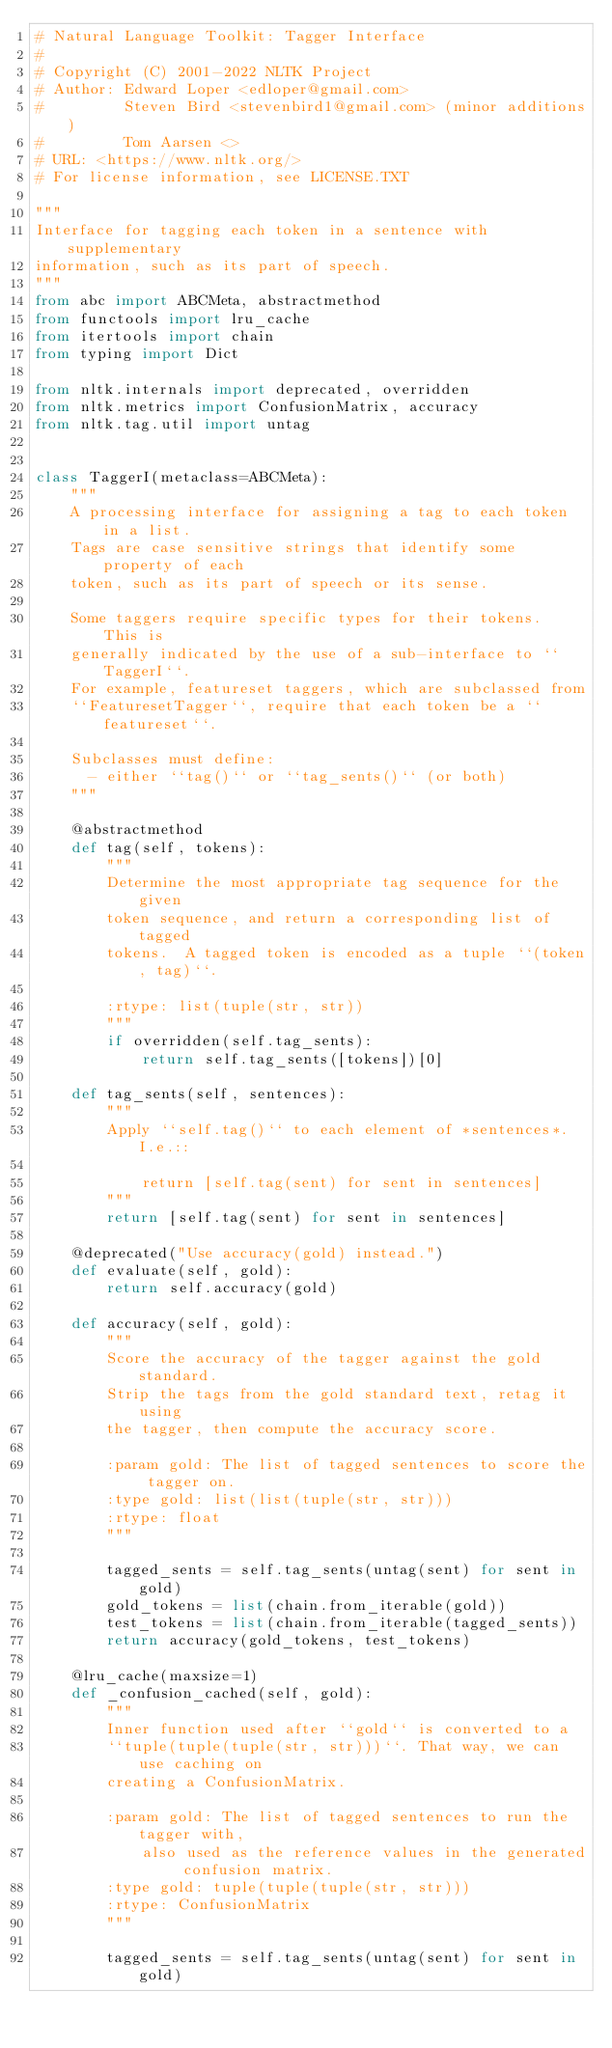Convert code to text. <code><loc_0><loc_0><loc_500><loc_500><_Python_># Natural Language Toolkit: Tagger Interface
#
# Copyright (C) 2001-2022 NLTK Project
# Author: Edward Loper <edloper@gmail.com>
#         Steven Bird <stevenbird1@gmail.com> (minor additions)
#         Tom Aarsen <>
# URL: <https://www.nltk.org/>
# For license information, see LICENSE.TXT

"""
Interface for tagging each token in a sentence with supplementary
information, such as its part of speech.
"""
from abc import ABCMeta, abstractmethod
from functools import lru_cache
from itertools import chain
from typing import Dict

from nltk.internals import deprecated, overridden
from nltk.metrics import ConfusionMatrix, accuracy
from nltk.tag.util import untag


class TaggerI(metaclass=ABCMeta):
    """
    A processing interface for assigning a tag to each token in a list.
    Tags are case sensitive strings that identify some property of each
    token, such as its part of speech or its sense.

    Some taggers require specific types for their tokens.  This is
    generally indicated by the use of a sub-interface to ``TaggerI``.
    For example, featureset taggers, which are subclassed from
    ``FeaturesetTagger``, require that each token be a ``featureset``.

    Subclasses must define:
      - either ``tag()`` or ``tag_sents()`` (or both)
    """

    @abstractmethod
    def tag(self, tokens):
        """
        Determine the most appropriate tag sequence for the given
        token sequence, and return a corresponding list of tagged
        tokens.  A tagged token is encoded as a tuple ``(token, tag)``.

        :rtype: list(tuple(str, str))
        """
        if overridden(self.tag_sents):
            return self.tag_sents([tokens])[0]

    def tag_sents(self, sentences):
        """
        Apply ``self.tag()`` to each element of *sentences*.  I.e.::

            return [self.tag(sent) for sent in sentences]
        """
        return [self.tag(sent) for sent in sentences]

    @deprecated("Use accuracy(gold) instead.")
    def evaluate(self, gold):
        return self.accuracy(gold)

    def accuracy(self, gold):
        """
        Score the accuracy of the tagger against the gold standard.
        Strip the tags from the gold standard text, retag it using
        the tagger, then compute the accuracy score.

        :param gold: The list of tagged sentences to score the tagger on.
        :type gold: list(list(tuple(str, str)))
        :rtype: float
        """

        tagged_sents = self.tag_sents(untag(sent) for sent in gold)
        gold_tokens = list(chain.from_iterable(gold))
        test_tokens = list(chain.from_iterable(tagged_sents))
        return accuracy(gold_tokens, test_tokens)

    @lru_cache(maxsize=1)
    def _confusion_cached(self, gold):
        """
        Inner function used after ``gold`` is converted to a
        ``tuple(tuple(tuple(str, str)))``. That way, we can use caching on
        creating a ConfusionMatrix.

        :param gold: The list of tagged sentences to run the tagger with,
            also used as the reference values in the generated confusion matrix.
        :type gold: tuple(tuple(tuple(str, str)))
        :rtype: ConfusionMatrix
        """

        tagged_sents = self.tag_sents(untag(sent) for sent in gold)</code> 